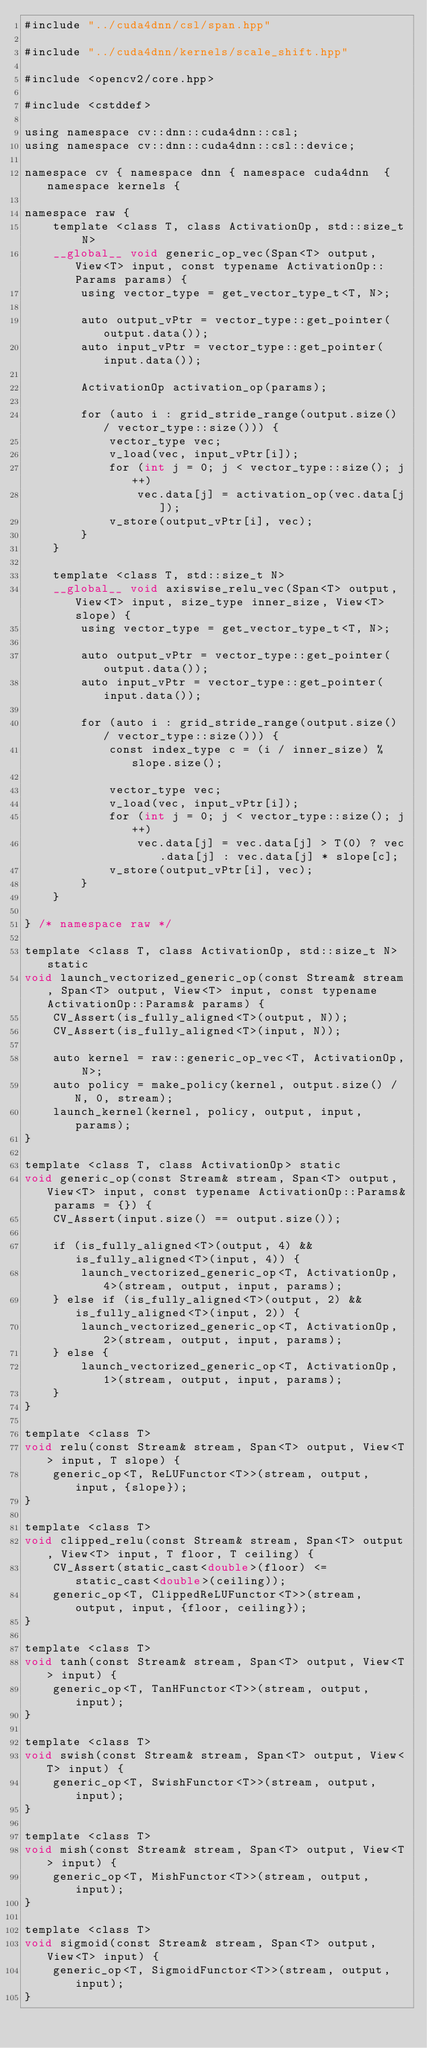<code> <loc_0><loc_0><loc_500><loc_500><_Cuda_>#include "../cuda4dnn/csl/span.hpp"

#include "../cuda4dnn/kernels/scale_shift.hpp"

#include <opencv2/core.hpp>

#include <cstddef>

using namespace cv::dnn::cuda4dnn::csl;
using namespace cv::dnn::cuda4dnn::csl::device;

namespace cv { namespace dnn { namespace cuda4dnn  { namespace kernels {

namespace raw {
    template <class T, class ActivationOp, std::size_t N>
    __global__ void generic_op_vec(Span<T> output, View<T> input, const typename ActivationOp::Params params) {
        using vector_type = get_vector_type_t<T, N>;

        auto output_vPtr = vector_type::get_pointer(output.data());
        auto input_vPtr = vector_type::get_pointer(input.data());

        ActivationOp activation_op(params);

        for (auto i : grid_stride_range(output.size() / vector_type::size())) {
            vector_type vec;
            v_load(vec, input_vPtr[i]);
            for (int j = 0; j < vector_type::size(); j++)
                vec.data[j] = activation_op(vec.data[j]);
            v_store(output_vPtr[i], vec);
        }
    }

    template <class T, std::size_t N>
    __global__ void axiswise_relu_vec(Span<T> output, View<T> input, size_type inner_size, View<T> slope) {
        using vector_type = get_vector_type_t<T, N>;

        auto output_vPtr = vector_type::get_pointer(output.data());
        auto input_vPtr = vector_type::get_pointer(input.data());

        for (auto i : grid_stride_range(output.size() / vector_type::size())) {
            const index_type c = (i / inner_size) % slope.size();

            vector_type vec;
            v_load(vec, input_vPtr[i]);
            for (int j = 0; j < vector_type::size(); j++)
                vec.data[j] = vec.data[j] > T(0) ? vec.data[j] : vec.data[j] * slope[c];
            v_store(output_vPtr[i], vec);
        }
    }

} /* namespace raw */

template <class T, class ActivationOp, std::size_t N> static
void launch_vectorized_generic_op(const Stream& stream, Span<T> output, View<T> input, const typename ActivationOp::Params& params) {
    CV_Assert(is_fully_aligned<T>(output, N));
    CV_Assert(is_fully_aligned<T>(input, N));

    auto kernel = raw::generic_op_vec<T, ActivationOp, N>;
    auto policy = make_policy(kernel, output.size() / N, 0, stream);
    launch_kernel(kernel, policy, output, input, params);
}

template <class T, class ActivationOp> static
void generic_op(const Stream& stream, Span<T> output, View<T> input, const typename ActivationOp::Params& params = {}) {
    CV_Assert(input.size() == output.size());

    if (is_fully_aligned<T>(output, 4) && is_fully_aligned<T>(input, 4)) {
        launch_vectorized_generic_op<T, ActivationOp, 4>(stream, output, input, params);
    } else if (is_fully_aligned<T>(output, 2) && is_fully_aligned<T>(input, 2)) {
        launch_vectorized_generic_op<T, ActivationOp, 2>(stream, output, input, params);
    } else {
        launch_vectorized_generic_op<T, ActivationOp, 1>(stream, output, input, params);
    }
}

template <class T>
void relu(const Stream& stream, Span<T> output, View<T> input, T slope) {
    generic_op<T, ReLUFunctor<T>>(stream, output, input, {slope});
}

template <class T>
void clipped_relu(const Stream& stream, Span<T> output, View<T> input, T floor, T ceiling) {
    CV_Assert(static_cast<double>(floor) <= static_cast<double>(ceiling));
    generic_op<T, ClippedReLUFunctor<T>>(stream, output, input, {floor, ceiling});
}

template <class T>
void tanh(const Stream& stream, Span<T> output, View<T> input) {
    generic_op<T, TanHFunctor<T>>(stream, output, input);
}

template <class T>
void swish(const Stream& stream, Span<T> output, View<T> input) {
    generic_op<T, SwishFunctor<T>>(stream, output, input);
}

template <class T>
void mish(const Stream& stream, Span<T> output, View<T> input) {
    generic_op<T, MishFunctor<T>>(stream, output, input);
}

template <class T>
void sigmoid(const Stream& stream, Span<T> output, View<T> input) {
    generic_op<T, SigmoidFunctor<T>>(stream, output, input);
}
</code> 